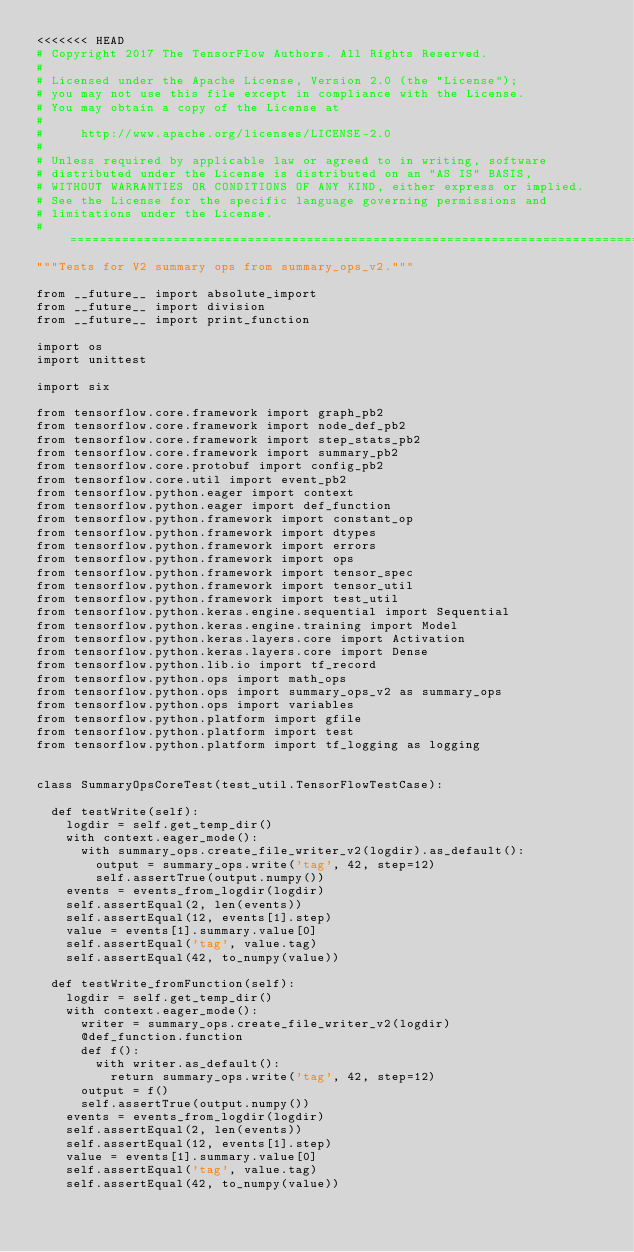<code> <loc_0><loc_0><loc_500><loc_500><_Python_><<<<<<< HEAD
# Copyright 2017 The TensorFlow Authors. All Rights Reserved.
#
# Licensed under the Apache License, Version 2.0 (the "License");
# you may not use this file except in compliance with the License.
# You may obtain a copy of the License at
#
#     http://www.apache.org/licenses/LICENSE-2.0
#
# Unless required by applicable law or agreed to in writing, software
# distributed under the License is distributed on an "AS IS" BASIS,
# WITHOUT WARRANTIES OR CONDITIONS OF ANY KIND, either express or implied.
# See the License for the specific language governing permissions and
# limitations under the License.
# ==============================================================================
"""Tests for V2 summary ops from summary_ops_v2."""

from __future__ import absolute_import
from __future__ import division
from __future__ import print_function

import os
import unittest

import six

from tensorflow.core.framework import graph_pb2
from tensorflow.core.framework import node_def_pb2
from tensorflow.core.framework import step_stats_pb2
from tensorflow.core.framework import summary_pb2
from tensorflow.core.protobuf import config_pb2
from tensorflow.core.util import event_pb2
from tensorflow.python.eager import context
from tensorflow.python.eager import def_function
from tensorflow.python.framework import constant_op
from tensorflow.python.framework import dtypes
from tensorflow.python.framework import errors
from tensorflow.python.framework import ops
from tensorflow.python.framework import tensor_spec
from tensorflow.python.framework import tensor_util
from tensorflow.python.framework import test_util
from tensorflow.python.keras.engine.sequential import Sequential
from tensorflow.python.keras.engine.training import Model
from tensorflow.python.keras.layers.core import Activation
from tensorflow.python.keras.layers.core import Dense
from tensorflow.python.lib.io import tf_record
from tensorflow.python.ops import math_ops
from tensorflow.python.ops import summary_ops_v2 as summary_ops
from tensorflow.python.ops import variables
from tensorflow.python.platform import gfile
from tensorflow.python.platform import test
from tensorflow.python.platform import tf_logging as logging


class SummaryOpsCoreTest(test_util.TensorFlowTestCase):

  def testWrite(self):
    logdir = self.get_temp_dir()
    with context.eager_mode():
      with summary_ops.create_file_writer_v2(logdir).as_default():
        output = summary_ops.write('tag', 42, step=12)
        self.assertTrue(output.numpy())
    events = events_from_logdir(logdir)
    self.assertEqual(2, len(events))
    self.assertEqual(12, events[1].step)
    value = events[1].summary.value[0]
    self.assertEqual('tag', value.tag)
    self.assertEqual(42, to_numpy(value))

  def testWrite_fromFunction(self):
    logdir = self.get_temp_dir()
    with context.eager_mode():
      writer = summary_ops.create_file_writer_v2(logdir)
      @def_function.function
      def f():
        with writer.as_default():
          return summary_ops.write('tag', 42, step=12)
      output = f()
      self.assertTrue(output.numpy())
    events = events_from_logdir(logdir)
    self.assertEqual(2, len(events))
    self.assertEqual(12, events[1].step)
    value = events[1].summary.value[0]
    self.assertEqual('tag', value.tag)
    self.assertEqual(42, to_numpy(value))
</code> 